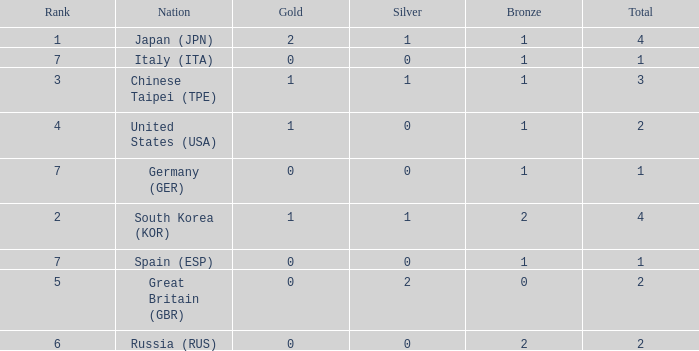For a country with more than a single silver medal, what is the overall number of medals they have? 2.0. 